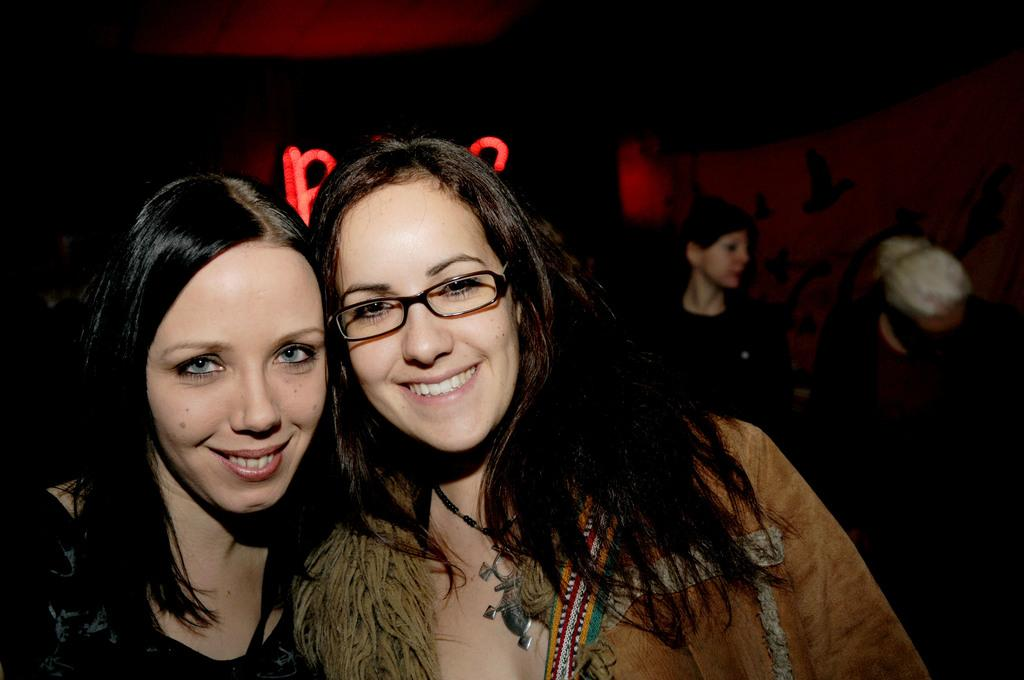How many women are in the image? There are two women in the image. What colors are the women's dresses? The women are wearing black and brown colored dresses. What expression do the women have in the image? The women are smiling. Can you describe the background of the image? The background of the image is dark, and there are other persons visible in the background. What type of thread is being used to secure the locket around the neck of one of the women in the image? There is no locket or thread present in the image; the women are wearing dresses and smiling. 